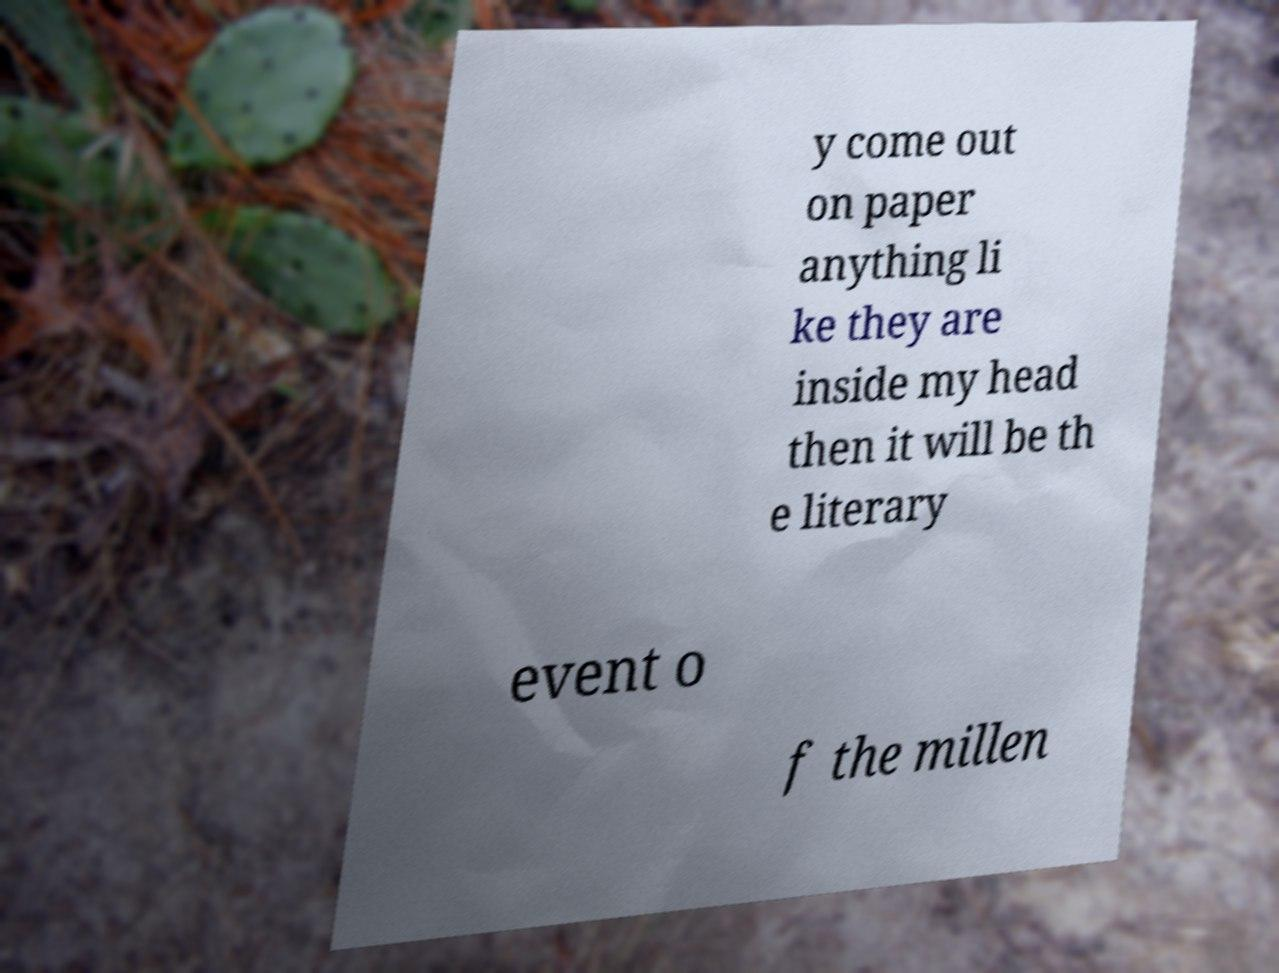For documentation purposes, I need the text within this image transcribed. Could you provide that? y come out on paper anything li ke they are inside my head then it will be th e literary event o f the millen 